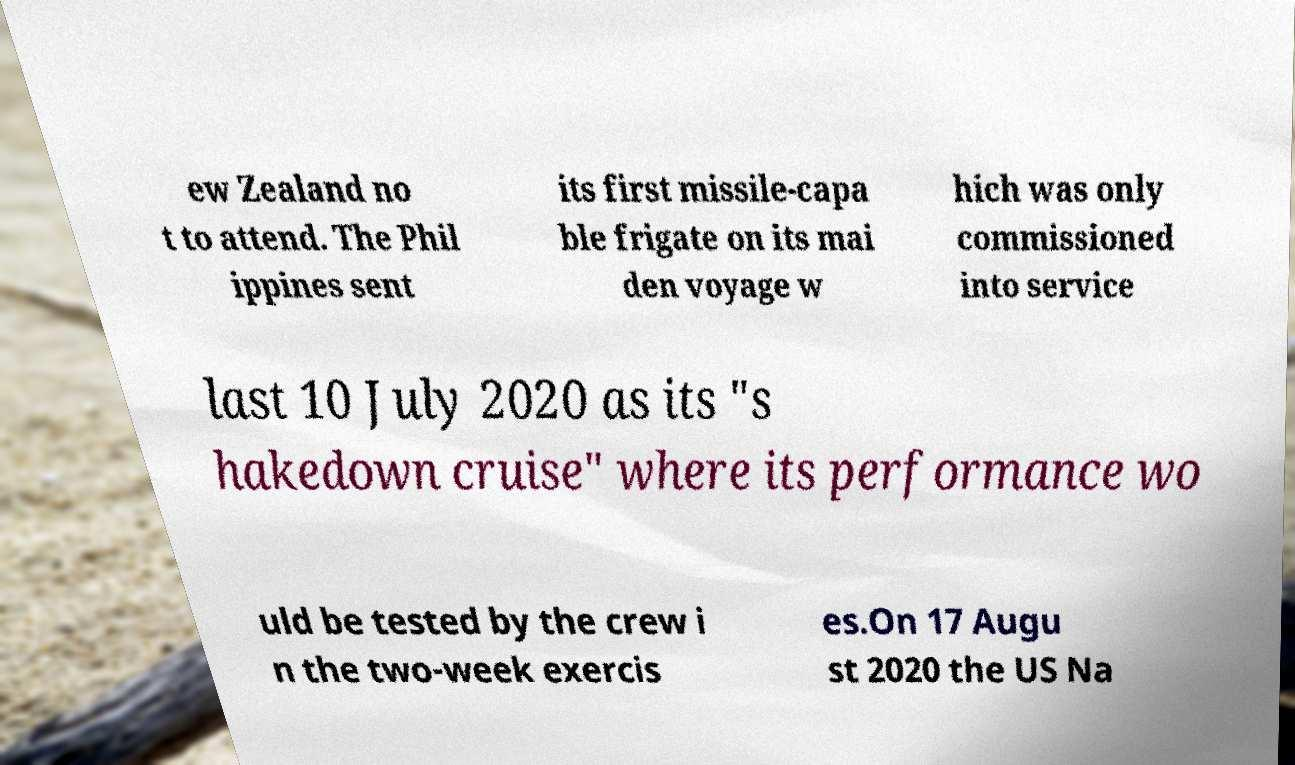Could you assist in decoding the text presented in this image and type it out clearly? ew Zealand no t to attend. The Phil ippines sent its first missile-capa ble frigate on its mai den voyage w hich was only commissioned into service last 10 July 2020 as its "s hakedown cruise" where its performance wo uld be tested by the crew i n the two-week exercis es.On 17 Augu st 2020 the US Na 